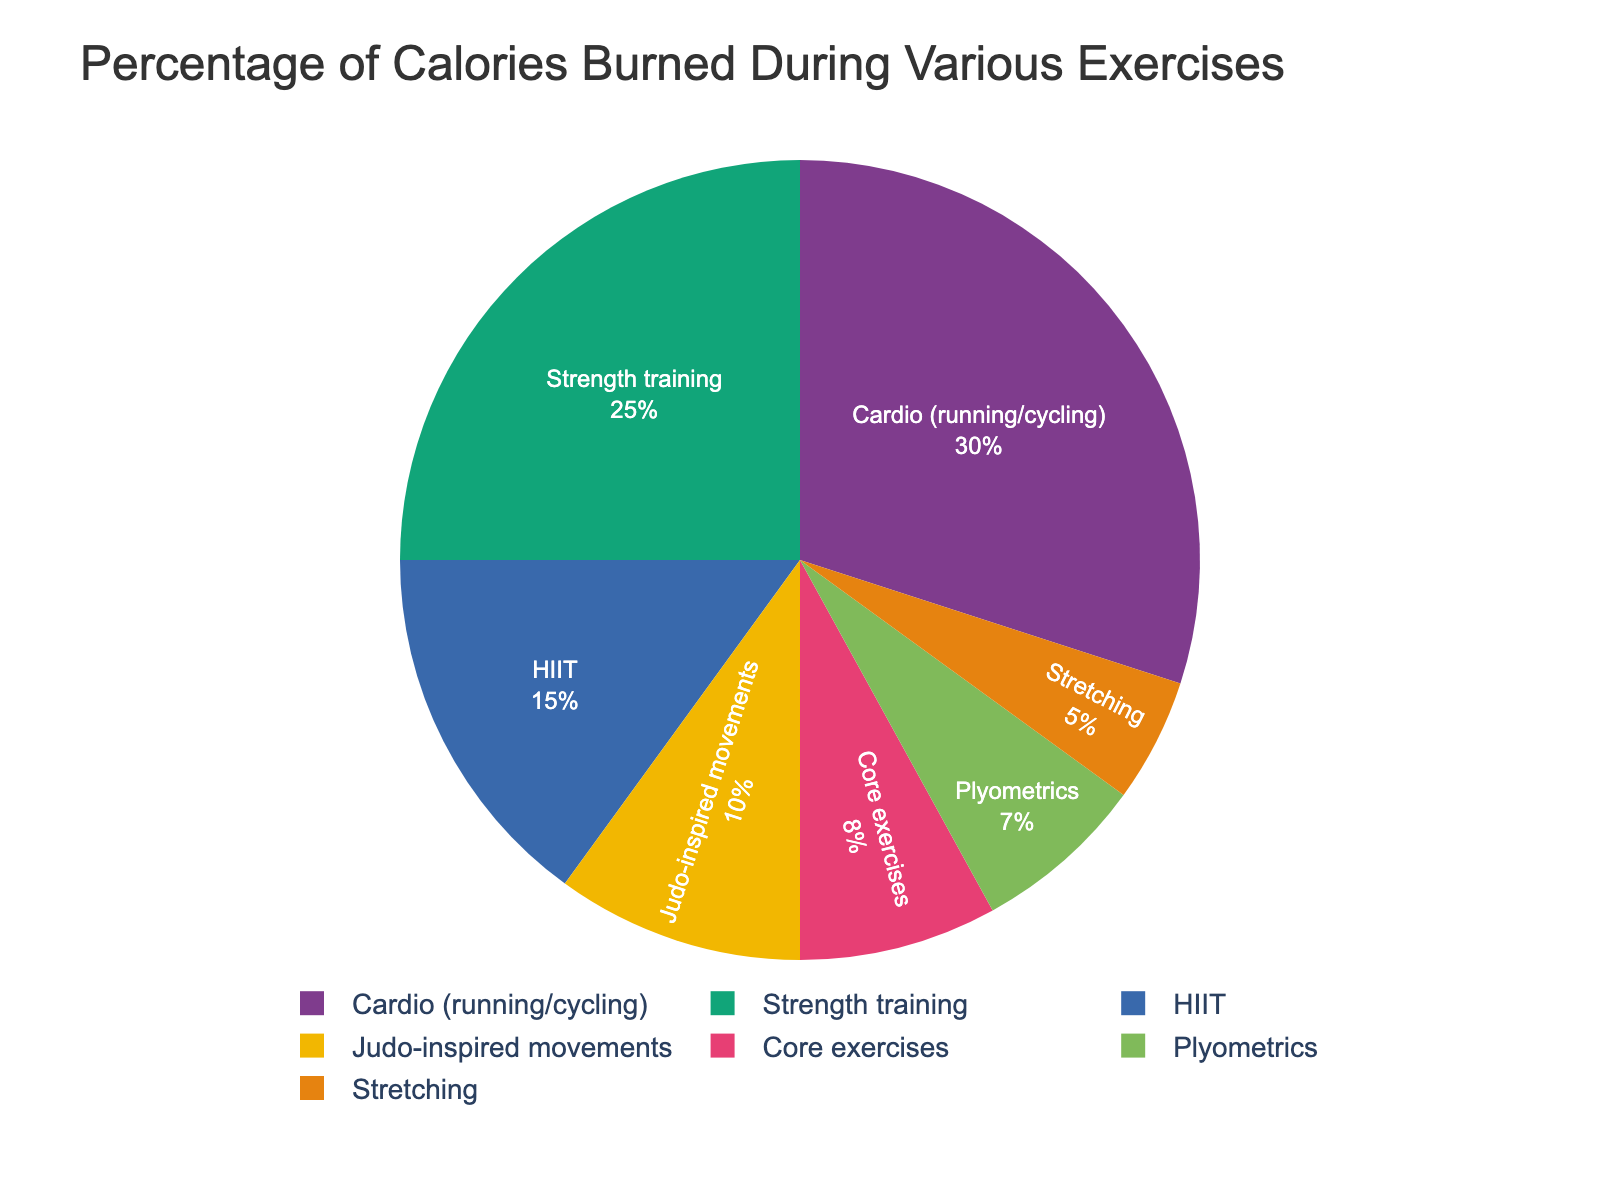What exercise burns the highest percentage of calories? Look at the pie chart and identify the exercise with the largest slice. The exercise labeled "Cardio (running/cycling)" takes up the largest portion.
Answer: Cardio (running/cycling) Which two exercises combined burn 40% of calories? Identify and sum the percentages of two slices that add up to 40%. "Strength training" burns 25% and "HIIT" burns 15%, combining for 40%.
Answer: Strength training and HIIT What is the percentage difference between Cardio and Judo-inspired movements? Subtract the percentage of calories burned by Judo-inspired movements from Cardio. Cardio burns 30% while Judo-inspired movements burn 10%, so 30% - 10% = 20%.
Answer: 20% Which exercise burns fewer calories, Core exercises or Plyometrics? Compare the slices labeled "Core exercises" and "Plyometrics". Core exercises account for 8%, while Plyometrics account for 7%.
Answer: Plyometrics What is the total percentage of calories burned by Stretching and Plyometrics combined? Add the percentages of "Stretching" and "Plyometrics". Stretching is 5% and Plyometrics is 7%, so 5% + 7% = 12%.
Answer: 12% Which exercise, HIIT or Core exercises, burns a higher percentage of calories? Compare the pie chart slices labeled "HIIT" and "Core exercises". "HIIT" burns 15% and "Core exercises" burn 8%.
Answer: HIIT What proportion of the total calories burned is contributed by Core exercises and Stretching together? Add the percentages of Core exercises and Stretching. Core exercises burn 8% and Stretching burns 5%, so 8% + 5% = 13%.
Answer: 13% If you combined the calories burned by Cardio and Strength training, would it be more than half of the total calories burned? Add the percentages for Cardio and Strength training and see if it is greater than 50%. Cardio is 30% and Strength training is 25%, so 30% + 25% = 55%, which is more than 50%.
Answer: Yes How much more percentage of calories is burned by Cardio (running/cycling) compared to Strength training? Subtract the percentage of Strength training from Cardio. Cardio burns 30% while Strength training burns 25%, so 30% - 25% = 5%.
Answer: 5% What is the combined percentage of calories burned by all exercises except Cardio? Sum the percentages of all exercises other than Cardio. This includes Strength training (25%), HIIT (15%), Stretching (5%), Judo-inspired movements (10%), Core exercises (8%), and Plyometrics (7%). So, 25% + 15% + 5% + 10% + 8% + 7% = 70%.
Answer: 70% 